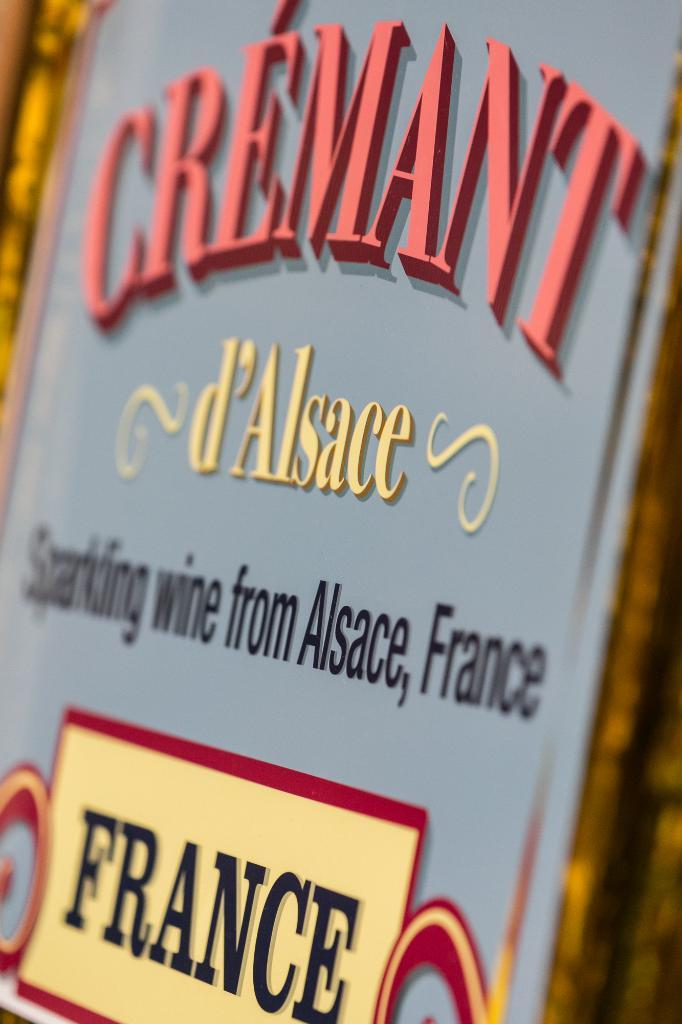<image>
Share a concise interpretation of the image provided. A sign for Cremant Sparkling wine from Alsace, France. 